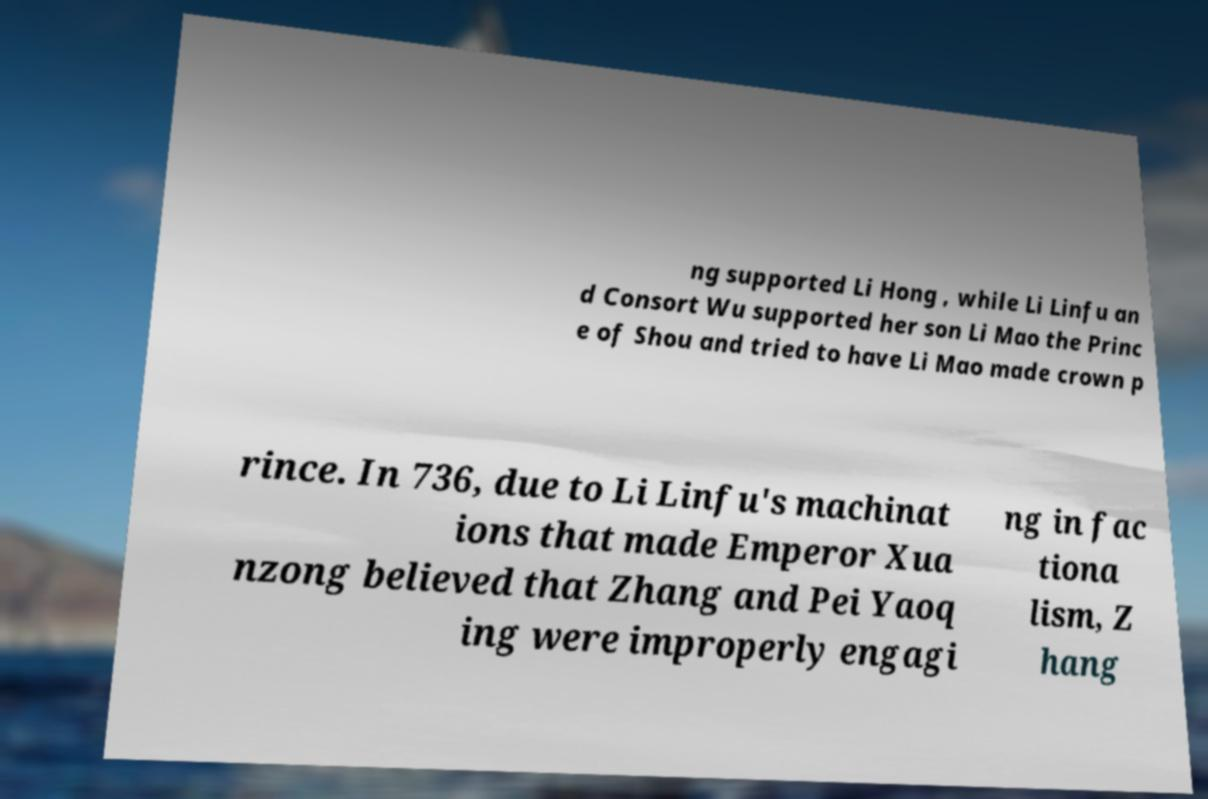Please read and relay the text visible in this image. What does it say? ng supported Li Hong , while Li Linfu an d Consort Wu supported her son Li Mao the Princ e of Shou and tried to have Li Mao made crown p rince. In 736, due to Li Linfu's machinat ions that made Emperor Xua nzong believed that Zhang and Pei Yaoq ing were improperly engagi ng in fac tiona lism, Z hang 